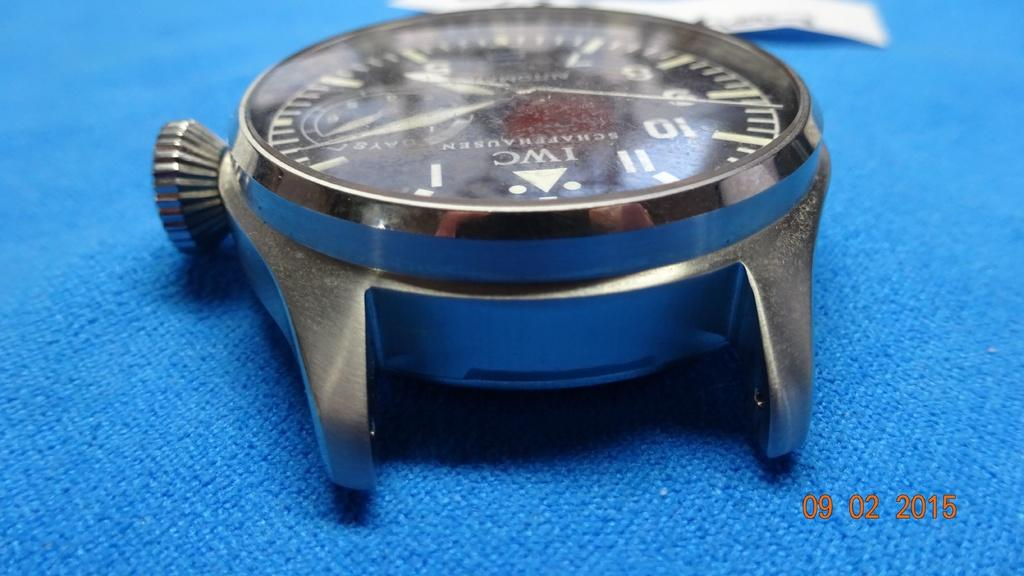<image>
Describe the image concisely. An IWC Schaffhauser watch face is shown in this picture dated 09.02.2015. 